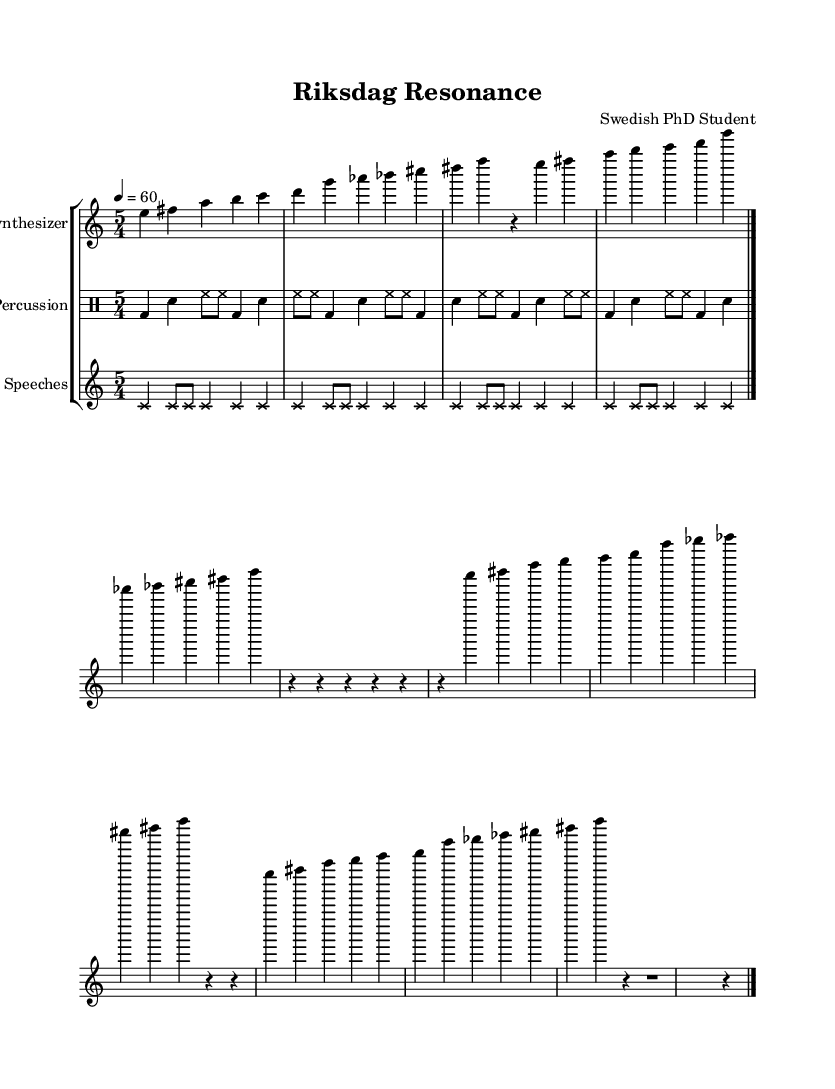What is the time signature of this composition? The time signature is found at the beginning of the music sheet, showing a "5/4" time, indicating there are five beats per measure.
Answer: 5/4 What is the key signature of this music? The key signature located at the beginning identifies C major, which has no sharps or flats present in the music.
Answer: C major What is the tempo marking for this piece? The tempo is indicated by "4 = 60," meaning it should be played at 60 beats per minute, with each quarter note representing one beat.
Answer: 60 How many measures does the electronic percussion part have? By counting the distinct sections in the electronic percussion part, we find there are four complete measures before the final bar line indicating the end.
Answer: 4 What is the main instrument used for the primary melody? The synthesizer is labeled as the instrument responsible for the primary melodic role, identifiable by the staff dedicated to it in the music sheet.
Answer: Synthesizer How does the sampled speeches section differ in style from the other parts? The sampled speeches section is characterized by cross note heads, which are visually distinct and indicate a different textual meaning or effect, contrasting with the standard note styling of other parts.
Answer: Cross note heads How many times is the twelve-tone row repeated in the synthesizer part? The synthesizer part indicates the twelve-tone row is played twice explicitly before the next rest measures, thus we can deduce it is repeated two times in the score.
Answer: 2 